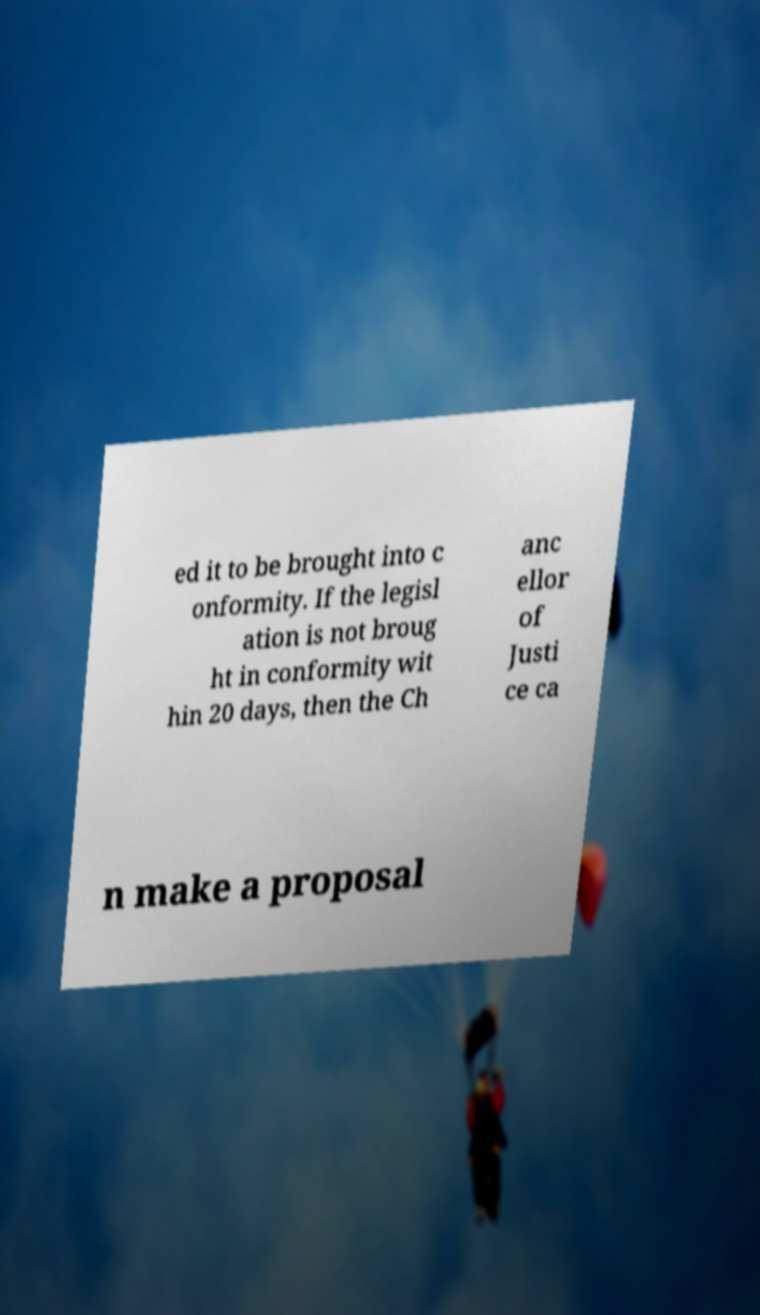Can you read and provide the text displayed in the image?This photo seems to have some interesting text. Can you extract and type it out for me? ed it to be brought into c onformity. If the legisl ation is not broug ht in conformity wit hin 20 days, then the Ch anc ellor of Justi ce ca n make a proposal 